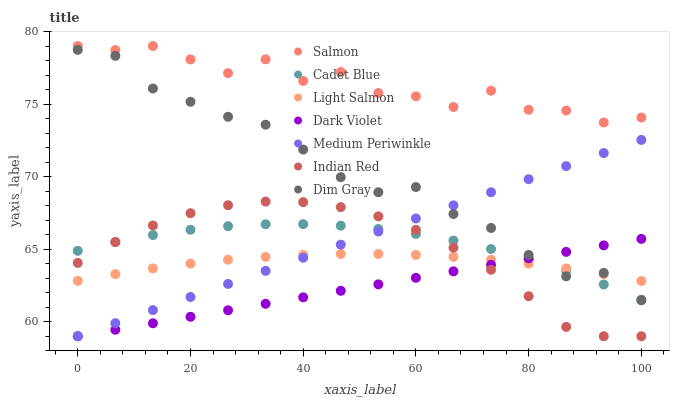Does Dark Violet have the minimum area under the curve?
Answer yes or no. Yes. Does Salmon have the maximum area under the curve?
Answer yes or no. Yes. Does Cadet Blue have the minimum area under the curve?
Answer yes or no. No. Does Cadet Blue have the maximum area under the curve?
Answer yes or no. No. Is Dark Violet the smoothest?
Answer yes or no. Yes. Is Salmon the roughest?
Answer yes or no. Yes. Is Cadet Blue the smoothest?
Answer yes or no. No. Is Cadet Blue the roughest?
Answer yes or no. No. Does Medium Periwinkle have the lowest value?
Answer yes or no. Yes. Does Cadet Blue have the lowest value?
Answer yes or no. No. Does Salmon have the highest value?
Answer yes or no. Yes. Does Cadet Blue have the highest value?
Answer yes or no. No. Is Medium Periwinkle less than Salmon?
Answer yes or no. Yes. Is Salmon greater than Cadet Blue?
Answer yes or no. Yes. Does Dark Violet intersect Light Salmon?
Answer yes or no. Yes. Is Dark Violet less than Light Salmon?
Answer yes or no. No. Is Dark Violet greater than Light Salmon?
Answer yes or no. No. Does Medium Periwinkle intersect Salmon?
Answer yes or no. No. 